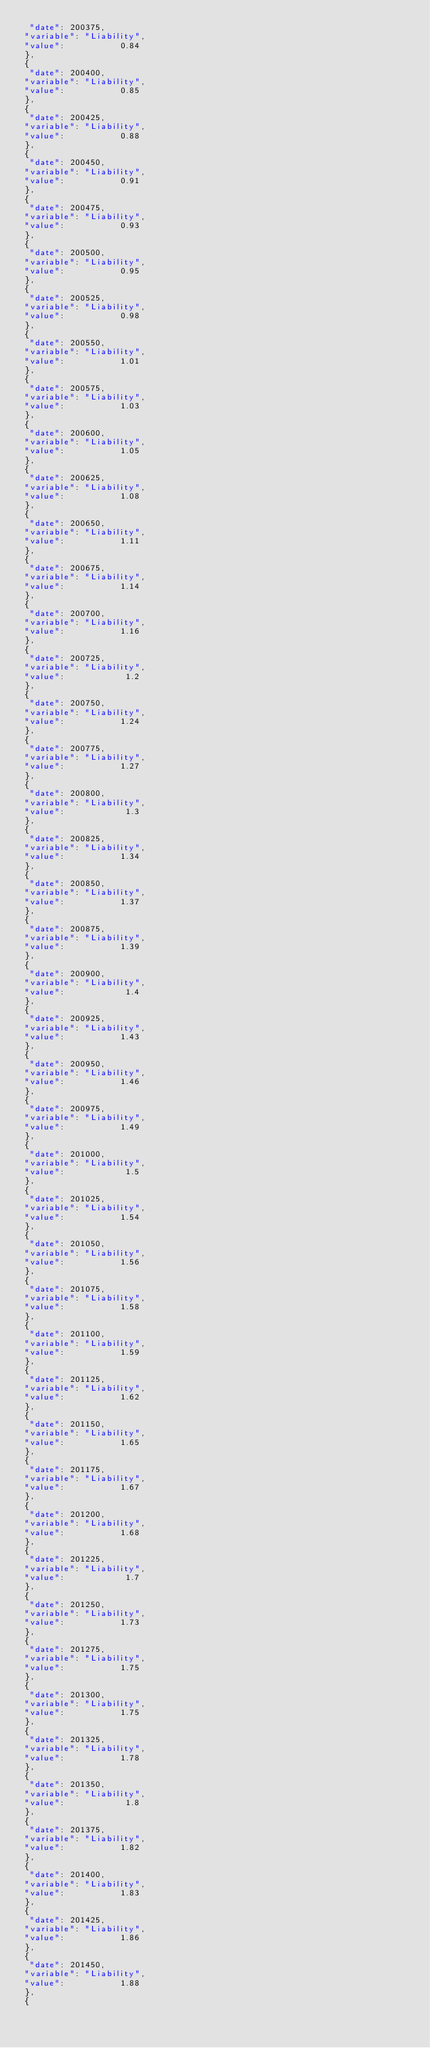Convert code to text. <code><loc_0><loc_0><loc_500><loc_500><_HTML_> "date": 200375,
"variable": "Liability",
"value":           0.84 
},
{
 "date": 200400,
"variable": "Liability",
"value":           0.85 
},
{
 "date": 200425,
"variable": "Liability",
"value":           0.88 
},
{
 "date": 200450,
"variable": "Liability",
"value":           0.91 
},
{
 "date": 200475,
"variable": "Liability",
"value":           0.93 
},
{
 "date": 200500,
"variable": "Liability",
"value":           0.95 
},
{
 "date": 200525,
"variable": "Liability",
"value":           0.98 
},
{
 "date": 200550,
"variable": "Liability",
"value":           1.01 
},
{
 "date": 200575,
"variable": "Liability",
"value":           1.03 
},
{
 "date": 200600,
"variable": "Liability",
"value":           1.05 
},
{
 "date": 200625,
"variable": "Liability",
"value":           1.08 
},
{
 "date": 200650,
"variable": "Liability",
"value":           1.11 
},
{
 "date": 200675,
"variable": "Liability",
"value":           1.14 
},
{
 "date": 200700,
"variable": "Liability",
"value":           1.16 
},
{
 "date": 200725,
"variable": "Liability",
"value":            1.2 
},
{
 "date": 200750,
"variable": "Liability",
"value":           1.24 
},
{
 "date": 200775,
"variable": "Liability",
"value":           1.27 
},
{
 "date": 200800,
"variable": "Liability",
"value":            1.3 
},
{
 "date": 200825,
"variable": "Liability",
"value":           1.34 
},
{
 "date": 200850,
"variable": "Liability",
"value":           1.37 
},
{
 "date": 200875,
"variable": "Liability",
"value":           1.39 
},
{
 "date": 200900,
"variable": "Liability",
"value":            1.4 
},
{
 "date": 200925,
"variable": "Liability",
"value":           1.43 
},
{
 "date": 200950,
"variable": "Liability",
"value":           1.46 
},
{
 "date": 200975,
"variable": "Liability",
"value":           1.49 
},
{
 "date": 201000,
"variable": "Liability",
"value":            1.5 
},
{
 "date": 201025,
"variable": "Liability",
"value":           1.54 
},
{
 "date": 201050,
"variable": "Liability",
"value":           1.56 
},
{
 "date": 201075,
"variable": "Liability",
"value":           1.58 
},
{
 "date": 201100,
"variable": "Liability",
"value":           1.59 
},
{
 "date": 201125,
"variable": "Liability",
"value":           1.62 
},
{
 "date": 201150,
"variable": "Liability",
"value":           1.65 
},
{
 "date": 201175,
"variable": "Liability",
"value":           1.67 
},
{
 "date": 201200,
"variable": "Liability",
"value":           1.68 
},
{
 "date": 201225,
"variable": "Liability",
"value":            1.7 
},
{
 "date": 201250,
"variable": "Liability",
"value":           1.73 
},
{
 "date": 201275,
"variable": "Liability",
"value":           1.75 
},
{
 "date": 201300,
"variable": "Liability",
"value":           1.75 
},
{
 "date": 201325,
"variable": "Liability",
"value":           1.78 
},
{
 "date": 201350,
"variable": "Liability",
"value":            1.8 
},
{
 "date": 201375,
"variable": "Liability",
"value":           1.82 
},
{
 "date": 201400,
"variable": "Liability",
"value":           1.83 
},
{
 "date": 201425,
"variable": "Liability",
"value":           1.86 
},
{
 "date": 201450,
"variable": "Liability",
"value":           1.88 
},
{</code> 